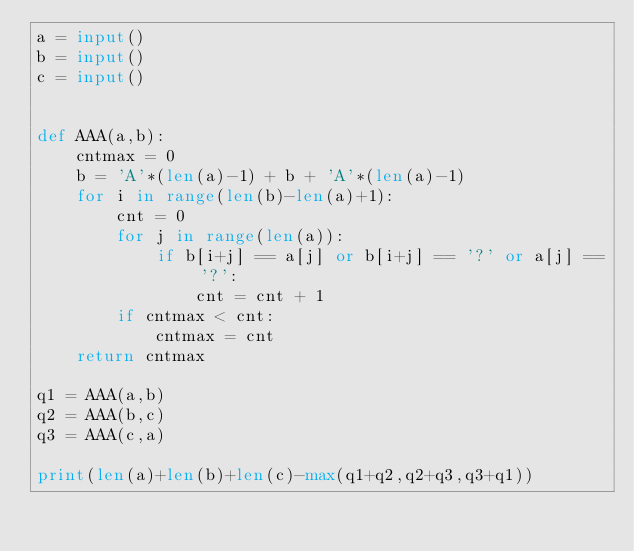Convert code to text. <code><loc_0><loc_0><loc_500><loc_500><_Python_>a = input()
b = input()
c = input()


def AAA(a,b):
    cntmax = 0
    b = 'A'*(len(a)-1) + b + 'A'*(len(a)-1)
    for i in range(len(b)-len(a)+1):
        cnt = 0
        for j in range(len(a)):
            if b[i+j] == a[j] or b[i+j] == '?' or a[j] == '?':
                cnt = cnt + 1
        if cntmax < cnt:
            cntmax = cnt
    return cntmax

q1 = AAA(a,b)
q2 = AAA(b,c)
q3 = AAA(c,a)

print(len(a)+len(b)+len(c)-max(q1+q2,q2+q3,q3+q1))</code> 